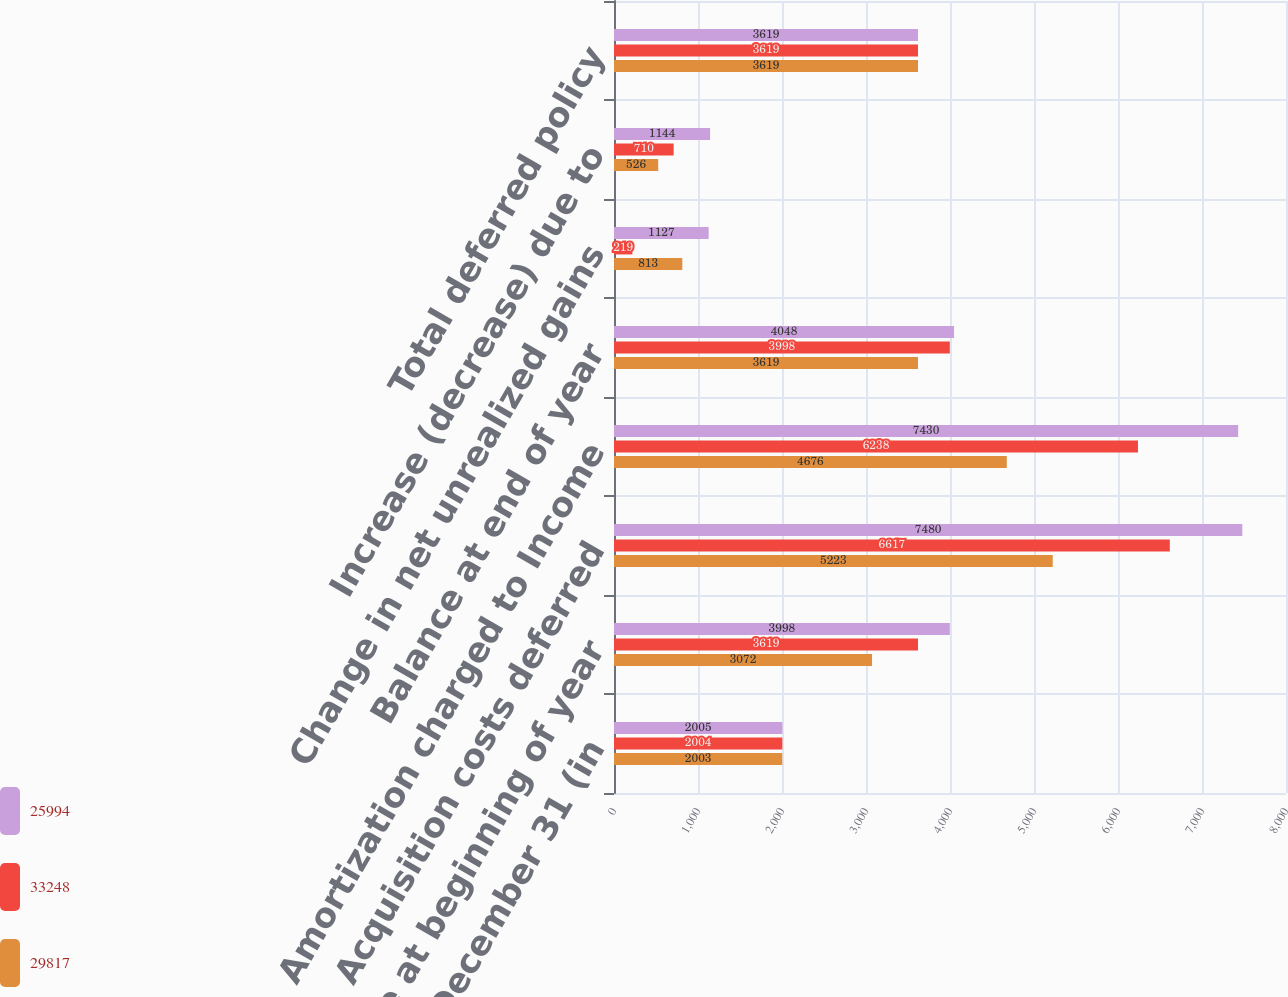Convert chart. <chart><loc_0><loc_0><loc_500><loc_500><stacked_bar_chart><ecel><fcel>Years Ended December 31 (in<fcel>Balance at beginning of year<fcel>Acquisition costs deferred<fcel>Amortization charged to Income<fcel>Balance at end of year<fcel>Change in net unrealized gains<fcel>Increase (decrease) due to<fcel>Total deferred policy<nl><fcel>25994<fcel>2005<fcel>3998<fcel>7480<fcel>7430<fcel>4048<fcel>1127<fcel>1144<fcel>3619<nl><fcel>33248<fcel>2004<fcel>3619<fcel>6617<fcel>6238<fcel>3998<fcel>219<fcel>710<fcel>3619<nl><fcel>29817<fcel>2003<fcel>3072<fcel>5223<fcel>4676<fcel>3619<fcel>813<fcel>526<fcel>3619<nl></chart> 